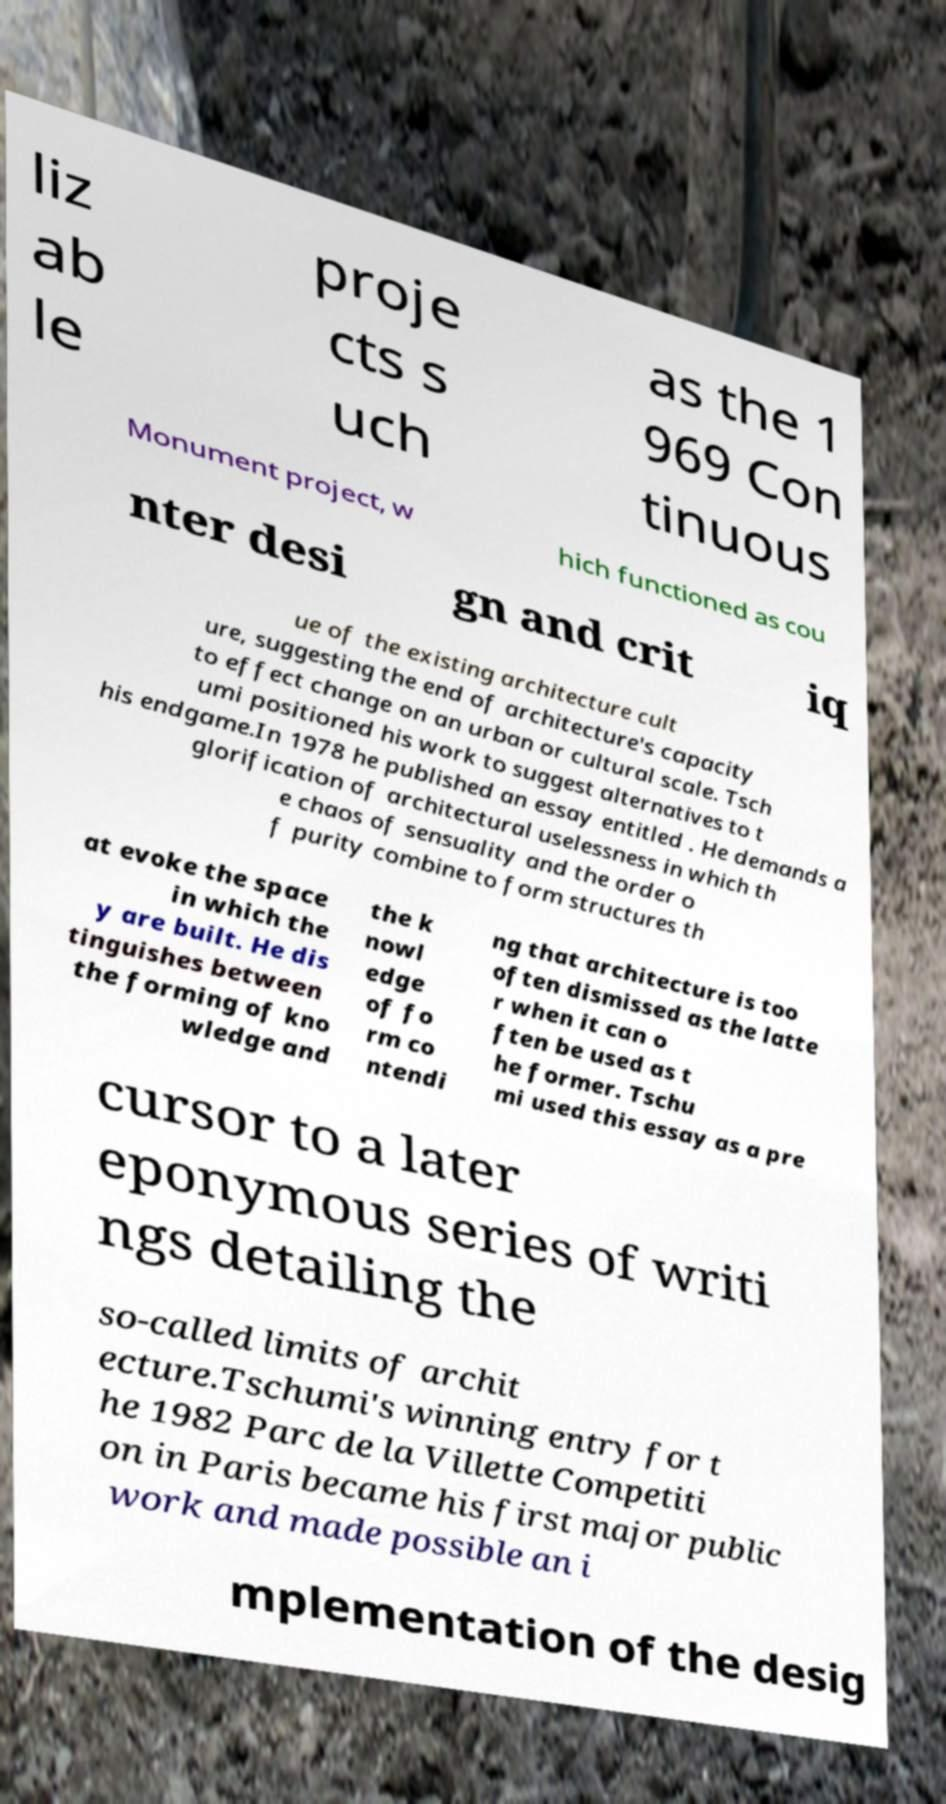What messages or text are displayed in this image? I need them in a readable, typed format. liz ab le proje cts s uch as the 1 969 Con tinuous Monument project, w hich functioned as cou nter desi gn and crit iq ue of the existing architecture cult ure, suggesting the end of architecture's capacity to effect change on an urban or cultural scale. Tsch umi positioned his work to suggest alternatives to t his endgame.In 1978 he published an essay entitled . He demands a glorification of architectural uselessness in which th e chaos of sensuality and the order o f purity combine to form structures th at evoke the space in which the y are built. He dis tinguishes between the forming of kno wledge and the k nowl edge of fo rm co ntendi ng that architecture is too often dismissed as the latte r when it can o ften be used as t he former. Tschu mi used this essay as a pre cursor to a later eponymous series of writi ngs detailing the so-called limits of archit ecture.Tschumi's winning entry for t he 1982 Parc de la Villette Competiti on in Paris became his first major public work and made possible an i mplementation of the desig 